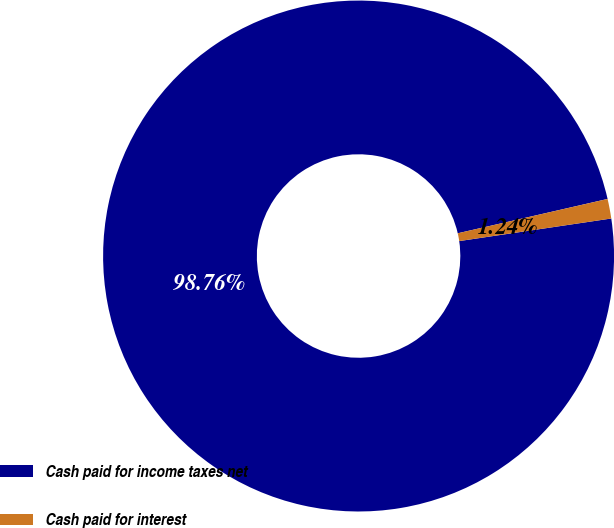Convert chart to OTSL. <chart><loc_0><loc_0><loc_500><loc_500><pie_chart><fcel>Cash paid for income taxes net<fcel>Cash paid for interest<nl><fcel>98.76%<fcel>1.24%<nl></chart> 